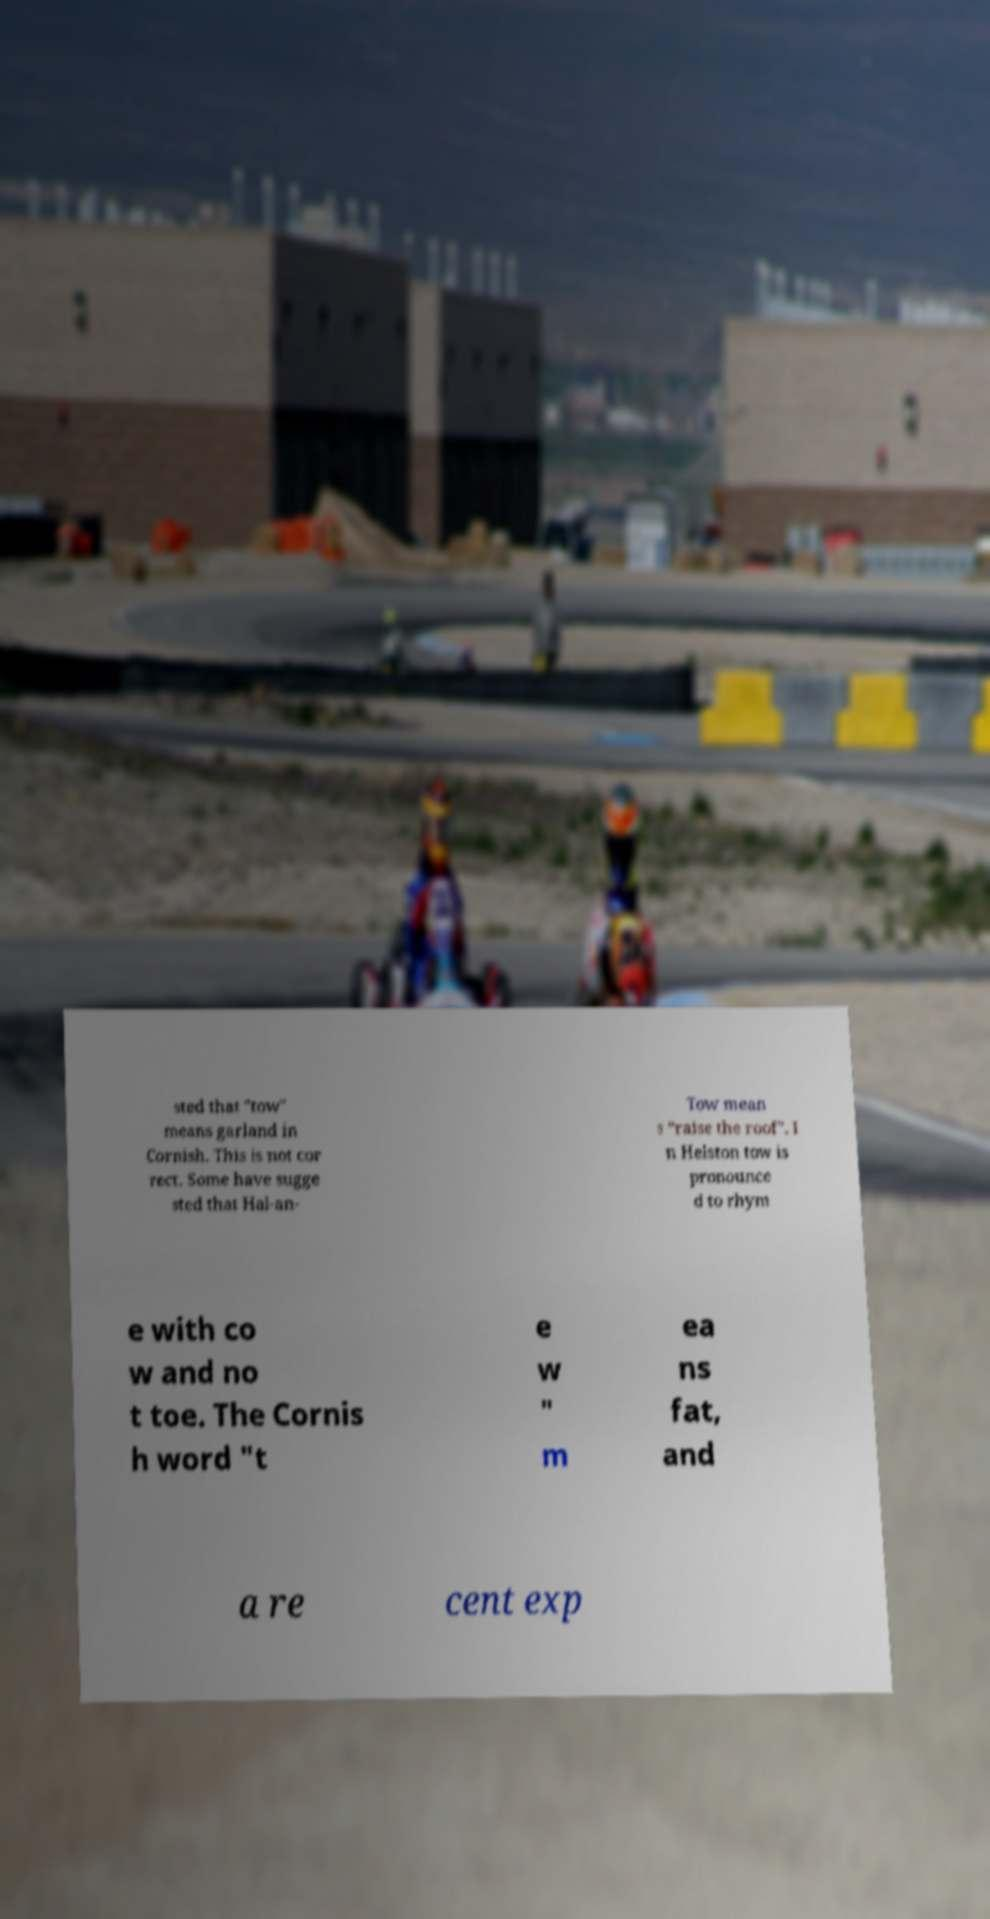I need the written content from this picture converted into text. Can you do that? sted that "tow" means garland in Cornish. This is not cor rect. Some have sugge sted that Hal-an- Tow mean s “raise the roof". I n Helston tow is pronounce d to rhym e with co w and no t toe. The Cornis h word "t e w " m ea ns fat, and a re cent exp 